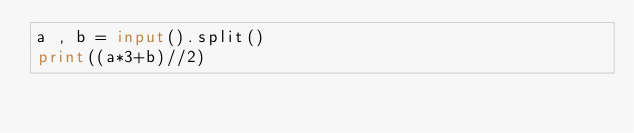<code> <loc_0><loc_0><loc_500><loc_500><_Python_>a , b = input().split()
print((a*3+b)//2)</code> 